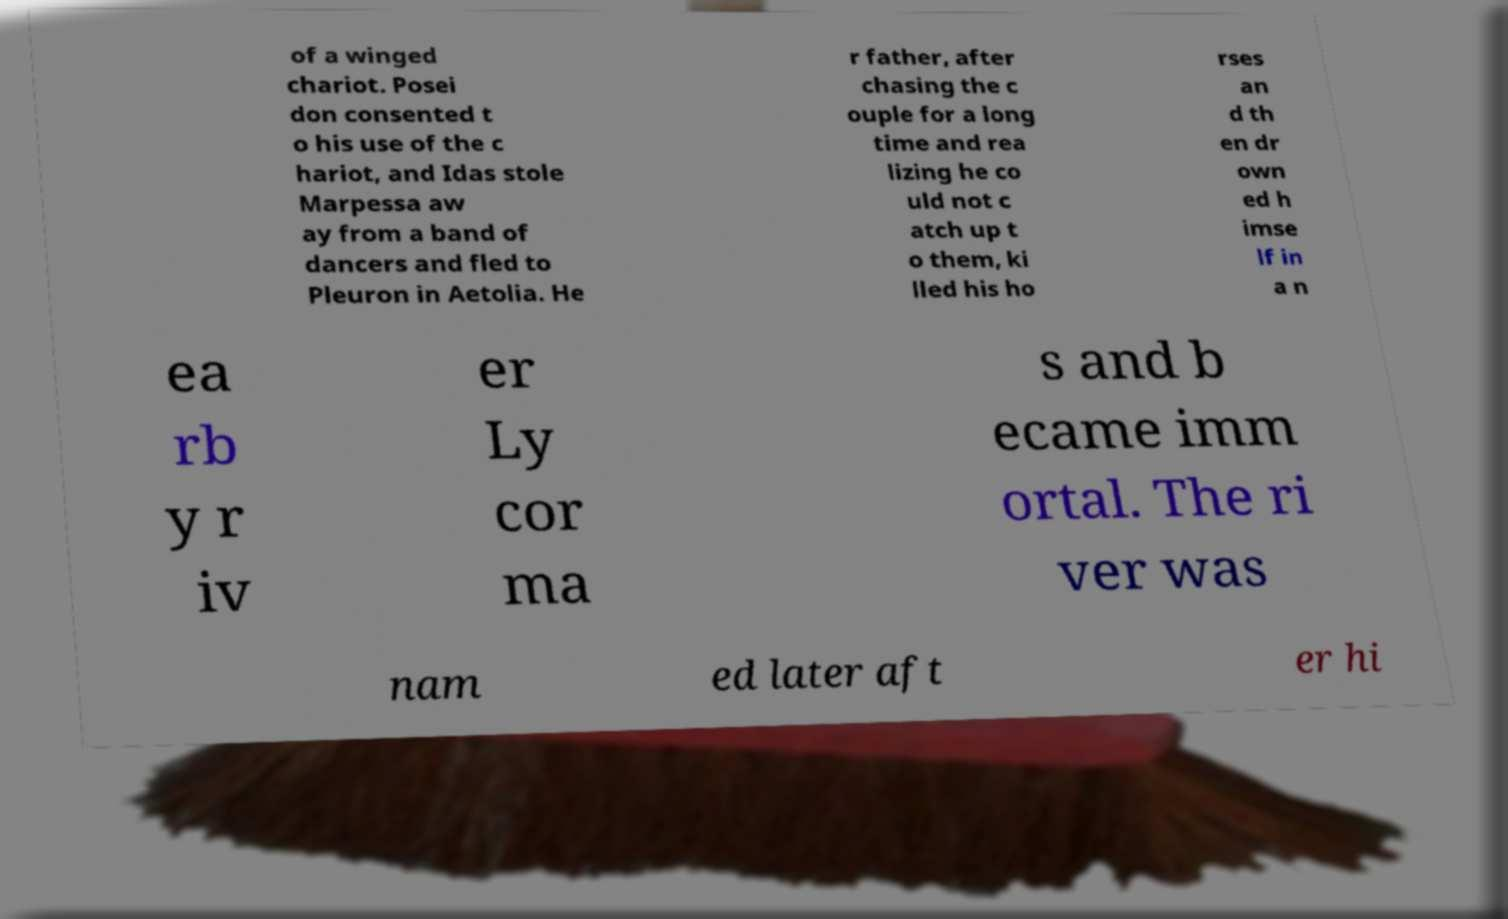I need the written content from this picture converted into text. Can you do that? of a winged chariot. Posei don consented t o his use of the c hariot, and Idas stole Marpessa aw ay from a band of dancers and fled to Pleuron in Aetolia. He r father, after chasing the c ouple for a long time and rea lizing he co uld not c atch up t o them, ki lled his ho rses an d th en dr own ed h imse lf in a n ea rb y r iv er Ly cor ma s and b ecame imm ortal. The ri ver was nam ed later aft er hi 